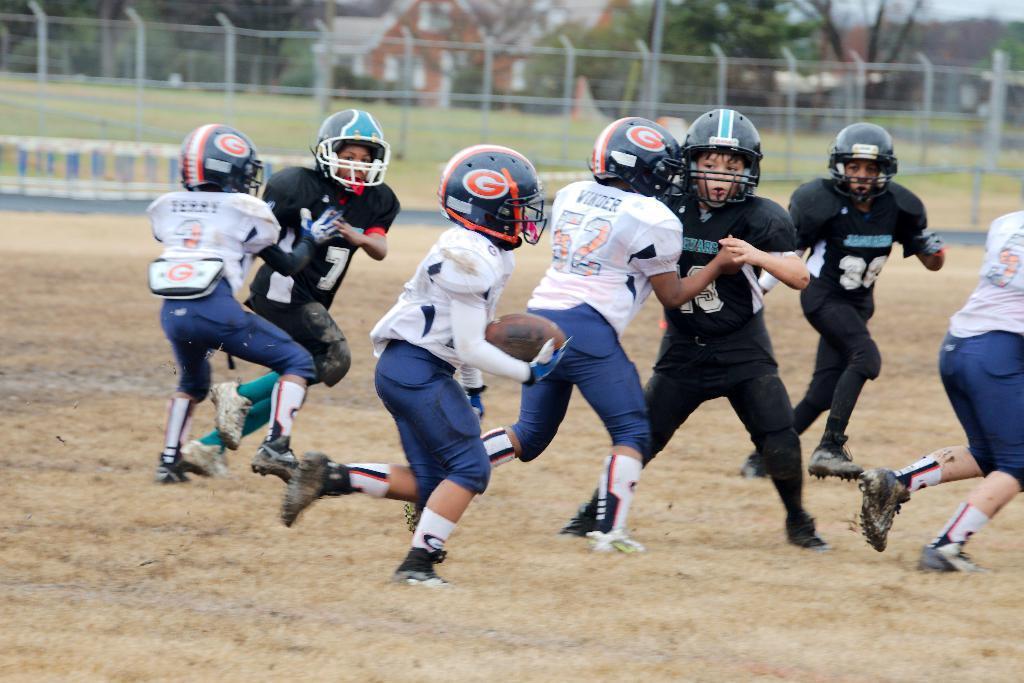Describe this image in one or two sentences. In this picture there are group of people in the center of the image, they are playing and there are houses, trees, and a net in the background area of the image. 